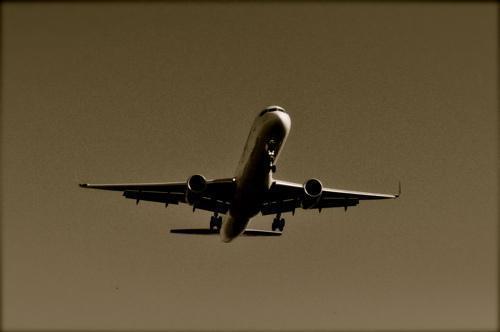How many planes are there?
Give a very brief answer. 1. How many engines does this aircraft have?
Give a very brief answer. 2. 